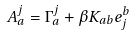<formula> <loc_0><loc_0><loc_500><loc_500>A ^ { j } _ { a } = \Gamma ^ { j } _ { a } + \beta K _ { a b } e ^ { b } _ { j }</formula> 